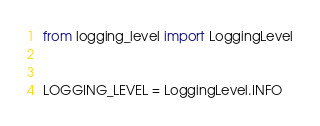Convert code to text. <code><loc_0><loc_0><loc_500><loc_500><_Python_>from logging_level import LoggingLevel


LOGGING_LEVEL = LoggingLevel.INFO</code> 